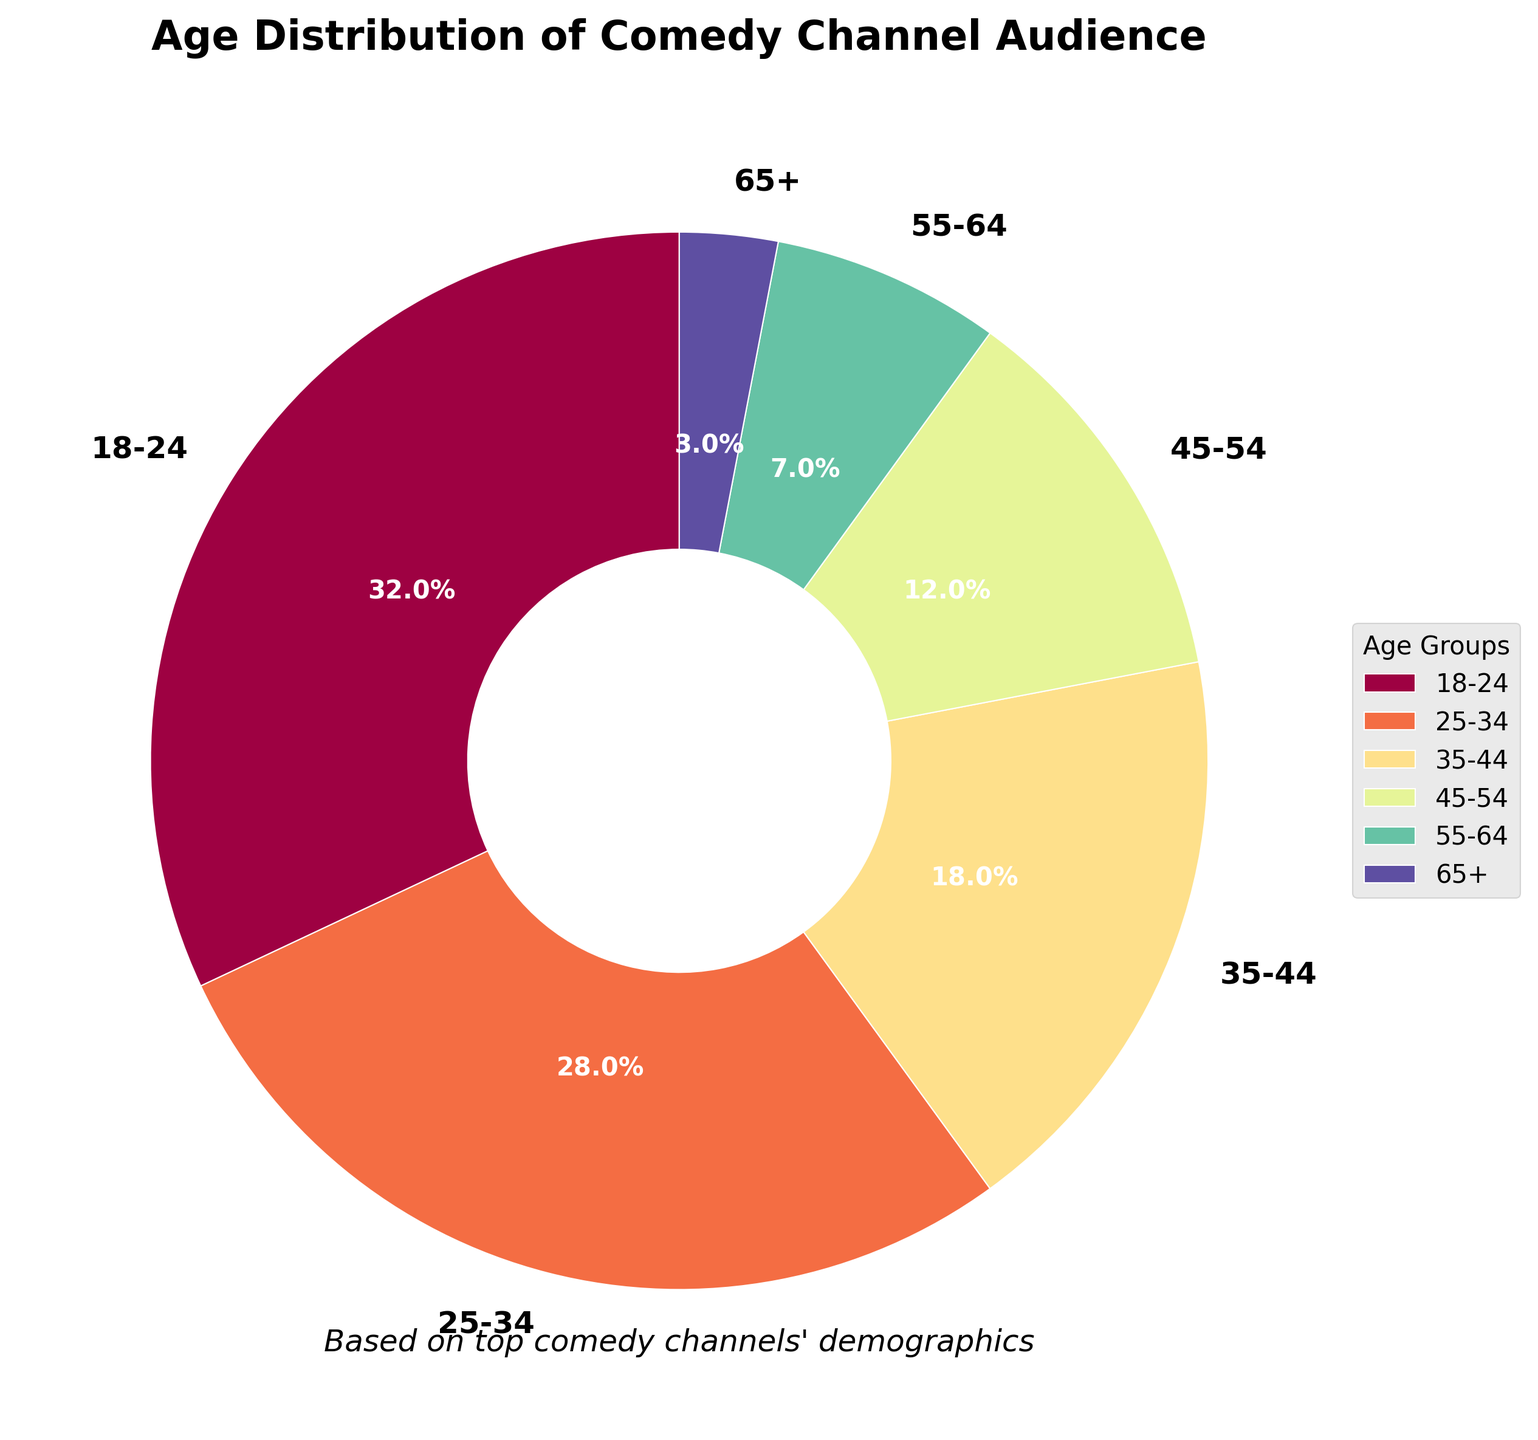What is the largest age group in the pie chart? The largest segment on the pie chart is the 18-24 age group. Its wedge is the largest and the percentage displayed is 32%.
Answer: 18-24 Which age group has roughly one-fifth of the audience? The 35-44 age group is shown to have 18%, which is approximately one-fifth of the total audience.
Answer: 35-44 Which two age groups together make up more than half of the audience? The 18-24 group has 32% and the 25-34 group has 28%. Together, they sum up to 60%, which is more than half of the audience.
Answer: 18-24 and 25-34 How does the 55-64 age group compare to the 25-34 age group in terms of audience percentage? The 55-64 age group has 7%, which is significantly smaller compared to the 25-34 age group, which has 28%.
Answer: 55-64 has less than 25-34 What percentage of the audience is older than 44? The 45-54 age group has 12%, the 55-64 group has 7%, and the 65+ group has 3%. Summing these gives 12% + 7% + 3% = 22%.
Answer: 22% Which part of the pie chart represents the smallest age group? The smallest segment is the 65+ group, which has the smallest wedge and a percentage of 3%.
Answer: 65+ What is the difference in percentage between the 18-24 age group and the 45-54 age group? The 18-24 age group has 32%, while the 45-54 age group has 12%. The difference is 32% - 12% = 20%.
Answer: 20% Can you identify which age group is third in terms of audience size? The third-largest age group is the 35-44 group, which has 18%. The first two are 18-24 (32%) and 25-34 (28%).
Answer: 35-44 What is the combined percentage of the youngest and oldest age groups? The 18-24 group has 32% and the 65+ group has 3%. Combined, they sum up to 32% + 3% = 35%.
Answer: 35% If the audience is divided into two halves, which age groups would make up the younger half? The younger half would include the 18-24 age group (32%) and the 25-34 age group (28%). Together, they total 60%, which is more than half.
Answer: 18-24 and 25-34 